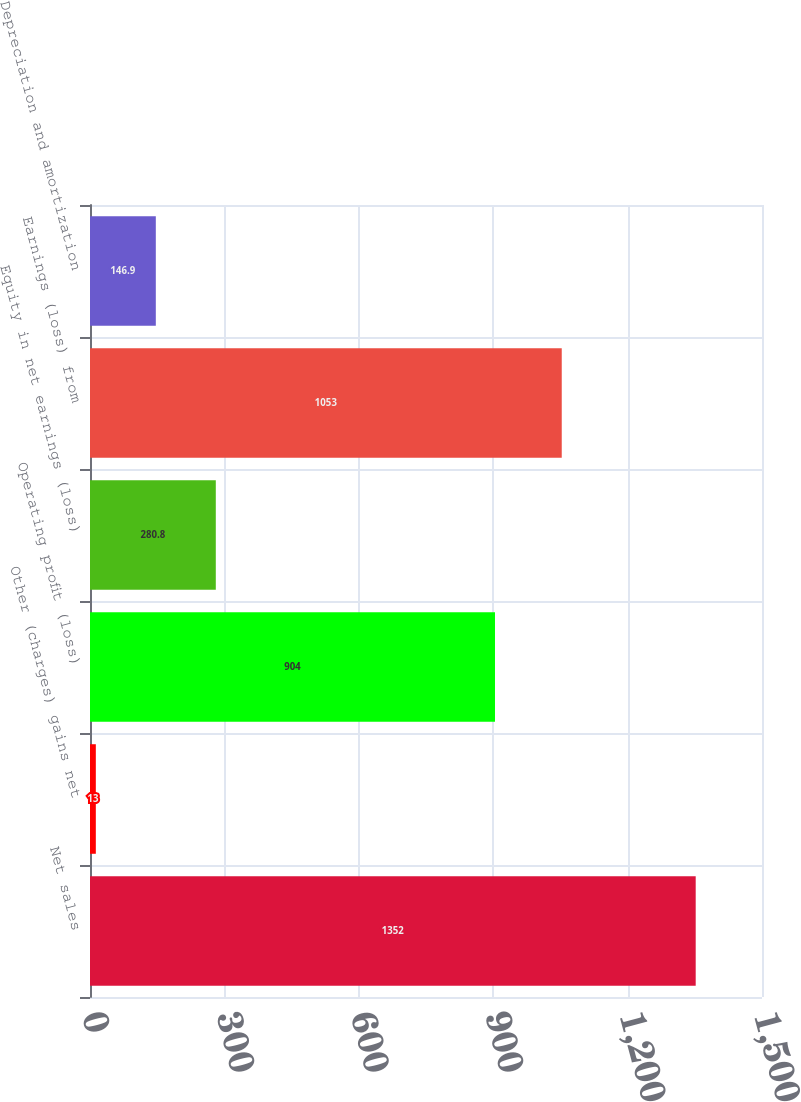<chart> <loc_0><loc_0><loc_500><loc_500><bar_chart><fcel>Net sales<fcel>Other (charges) gains net<fcel>Operating profit (loss)<fcel>Equity in net earnings (loss)<fcel>Earnings (loss) from<fcel>Depreciation and amortization<nl><fcel>1352<fcel>13<fcel>904<fcel>280.8<fcel>1053<fcel>146.9<nl></chart> 